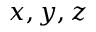Convert formula to latex. <formula><loc_0><loc_0><loc_500><loc_500>x , y , z</formula> 